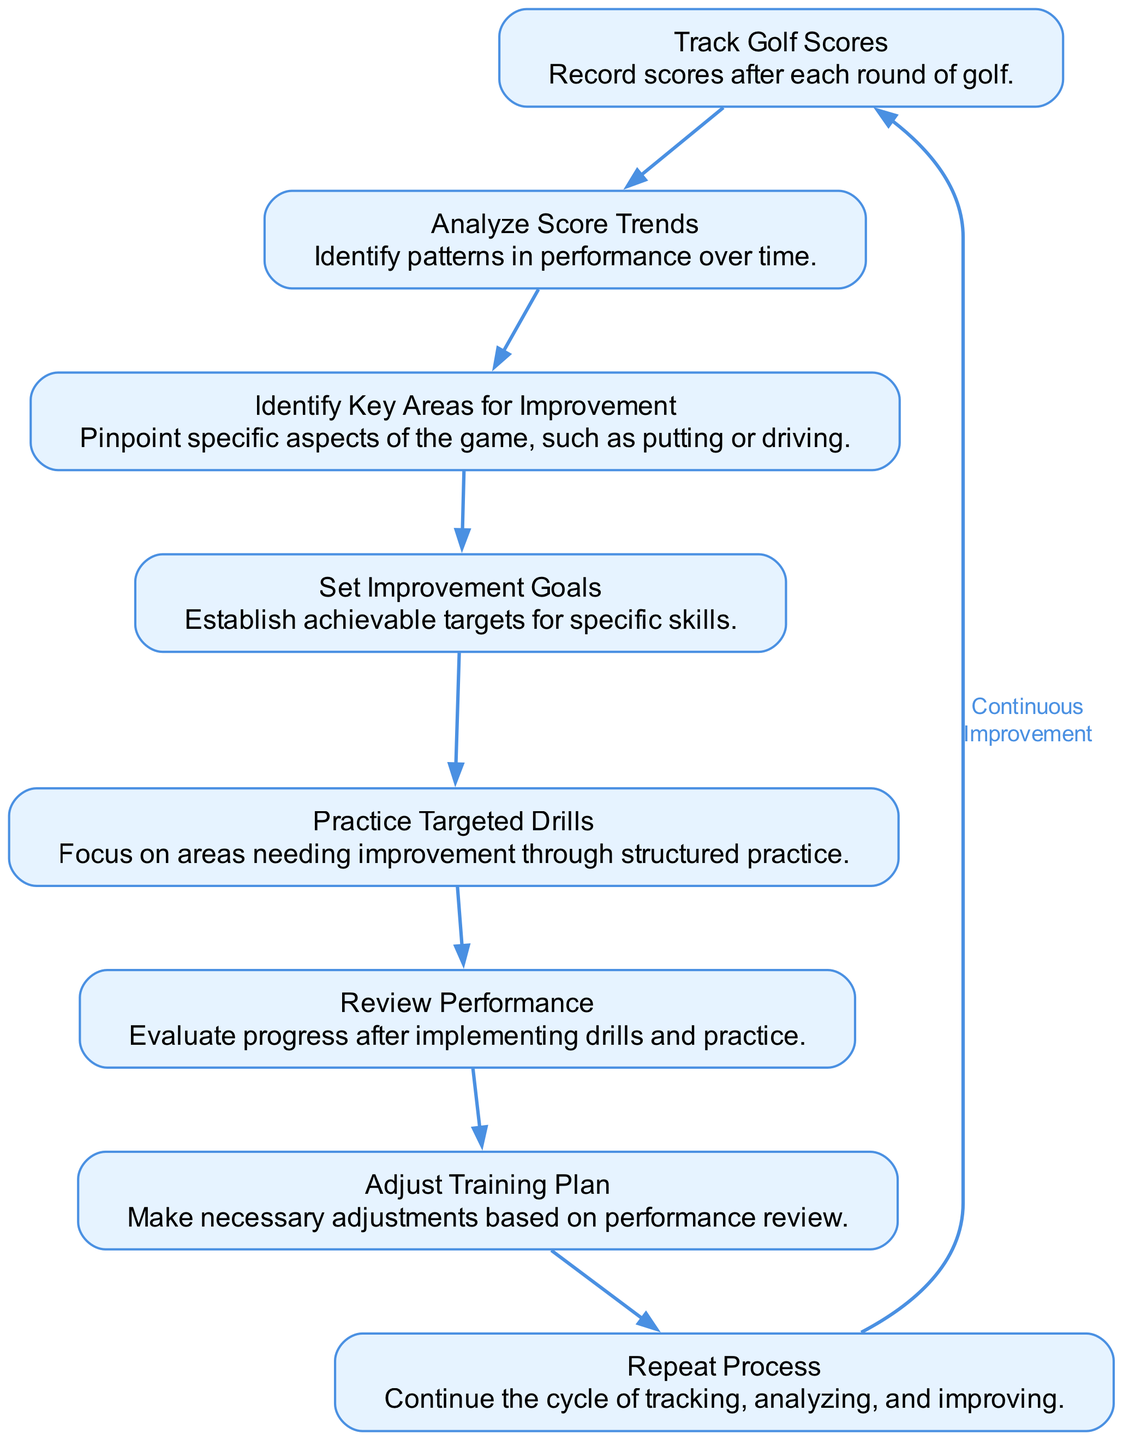What is the first step in the flow chart? The first step is "Track Golf Scores," which is the initial action in the process depicted in the diagram.
Answer: Track Golf Scores How many nodes are there in total? The diagram lists 8 distinct elements (nodes) representing different steps in the golf score improvement process.
Answer: 8 What is the last step before repeating the process? The last step before the cycle repeats is "Adjust Training Plan," as it precedes the "Repeat Process" node in the flow chart.
Answer: Adjust Training Plan What are the two main areas focused on in the improvement process? The process emphasizes "Practice Targeted Drills" and "Review Performance" as key stages in improving golf skills based on identified areas that need work.
Answer: Practice Targeted Drills and Review Performance Which step follows "Analyze Score Trends"? The next step after "Analyze Score Trends" is "Identify Key Areas for Improvement," indicating that after analyzing performance, specific focus areas are determined.
Answer: Identify Key Areas for Improvement How many edges connect the nodes in this flow chart? There are 8 edges connecting the nodes, as each step moves sequentially from one to the next, with an additional edge creating a cycle from the last back to the first node.
Answer: 8 Which nodes are directly linked to "Set Improvement Goals"? The node "Set Improvement Goals" is directly linked to "Identify Key Areas for Improvement" and then leads to "Practice Targeted Drills," indicating it is part of the improvement process that follows the identification of areas needing work.
Answer: Identify Key Areas for Improvement and Practice Targeted Drills What is the purpose of "Review Performance"? "Review Performance" serves to evaluate progress in the improvement process after targeted drills have been practiced, allowing for assessment of effectiveness.
Answer: Evaluate progress 